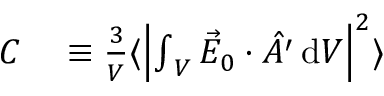Convert formula to latex. <formula><loc_0><loc_0><loc_500><loc_500>\begin{array} { r l } { C } & \equiv \frac { 3 } { V } \langle \left | { \int } _ { V } \, \vec { E } _ { 0 } \cdot \hat { A ^ { \prime } } \, d V \right | ^ { 2 } \rangle } \end{array}</formula> 